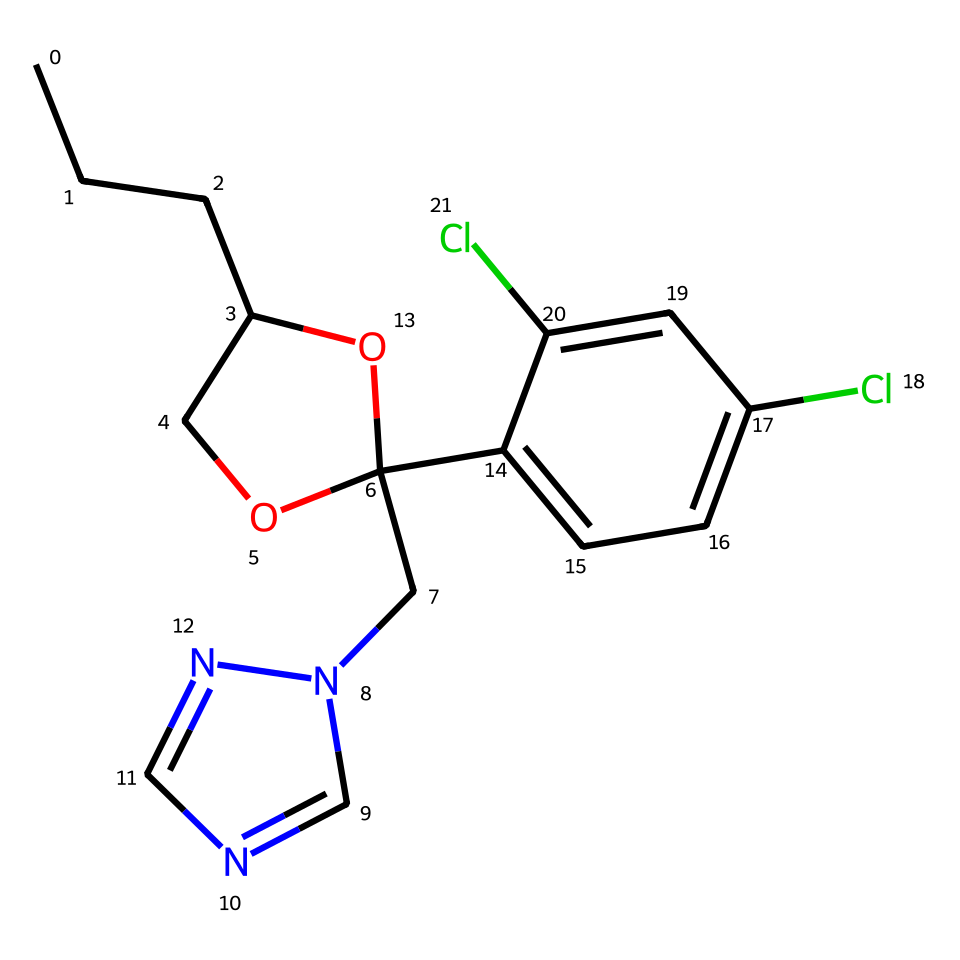What is the overall molecular formula of propiconazole? To derive the overall molecular formula, identify the different atoms in the SMILES representation. Counting each atom type leads to C13 (carbons), H16 (hydrogens), Cl2 (chlorines), N4 (nitrogens), and O1 (oxygen). Combining these gives us the formula: C13H16Cl2N4O.
Answer: C13H16Cl2N4O How many chlorine atoms are present in propiconazole? By examining the structure, there are two chlorine atoms attached to the aromatic ring. Each chlorine atom is noted in the SMILES representation before "cc".
Answer: 2 What functional groups are identified in propiconazole? The analysis of the structure reveals multiple functional groups, including a triazole ring (n2cncn2), an alcohol group (-OH), and two chlorobenzene groups (C6H3Cl2). These functional groups play a significant role in propiconazole's fungicidal activity.
Answer: triazole, alcohol, chlorobenzene Is propiconazole a saturated or unsaturated compound? A compound is considered saturated if it has no double or triple bonds. Upon examining the SMILES representation, all the carbon atoms are connected through single bonds in the aliphatic chain, suggesting that propiconazole is a saturated compound.
Answer: saturated What type of compound is propiconazole classified as? Based on its structure and the presence of a triazole ring, propiconazole is classified as a triazole fungicide. Its specific molecular structure suggests it works by inhibiting certain fungal enzyme processes.
Answer: triazole fungicide Which part of the molecule is responsible for its fungicidal properties? The triazole ring (n2cncn2) is critical in propiconazole's mechanism of action, as it interacts with fungal enzymes involved in ergosterol biosynthesis, effectively hindering fungal growth.
Answer: triazole ring 